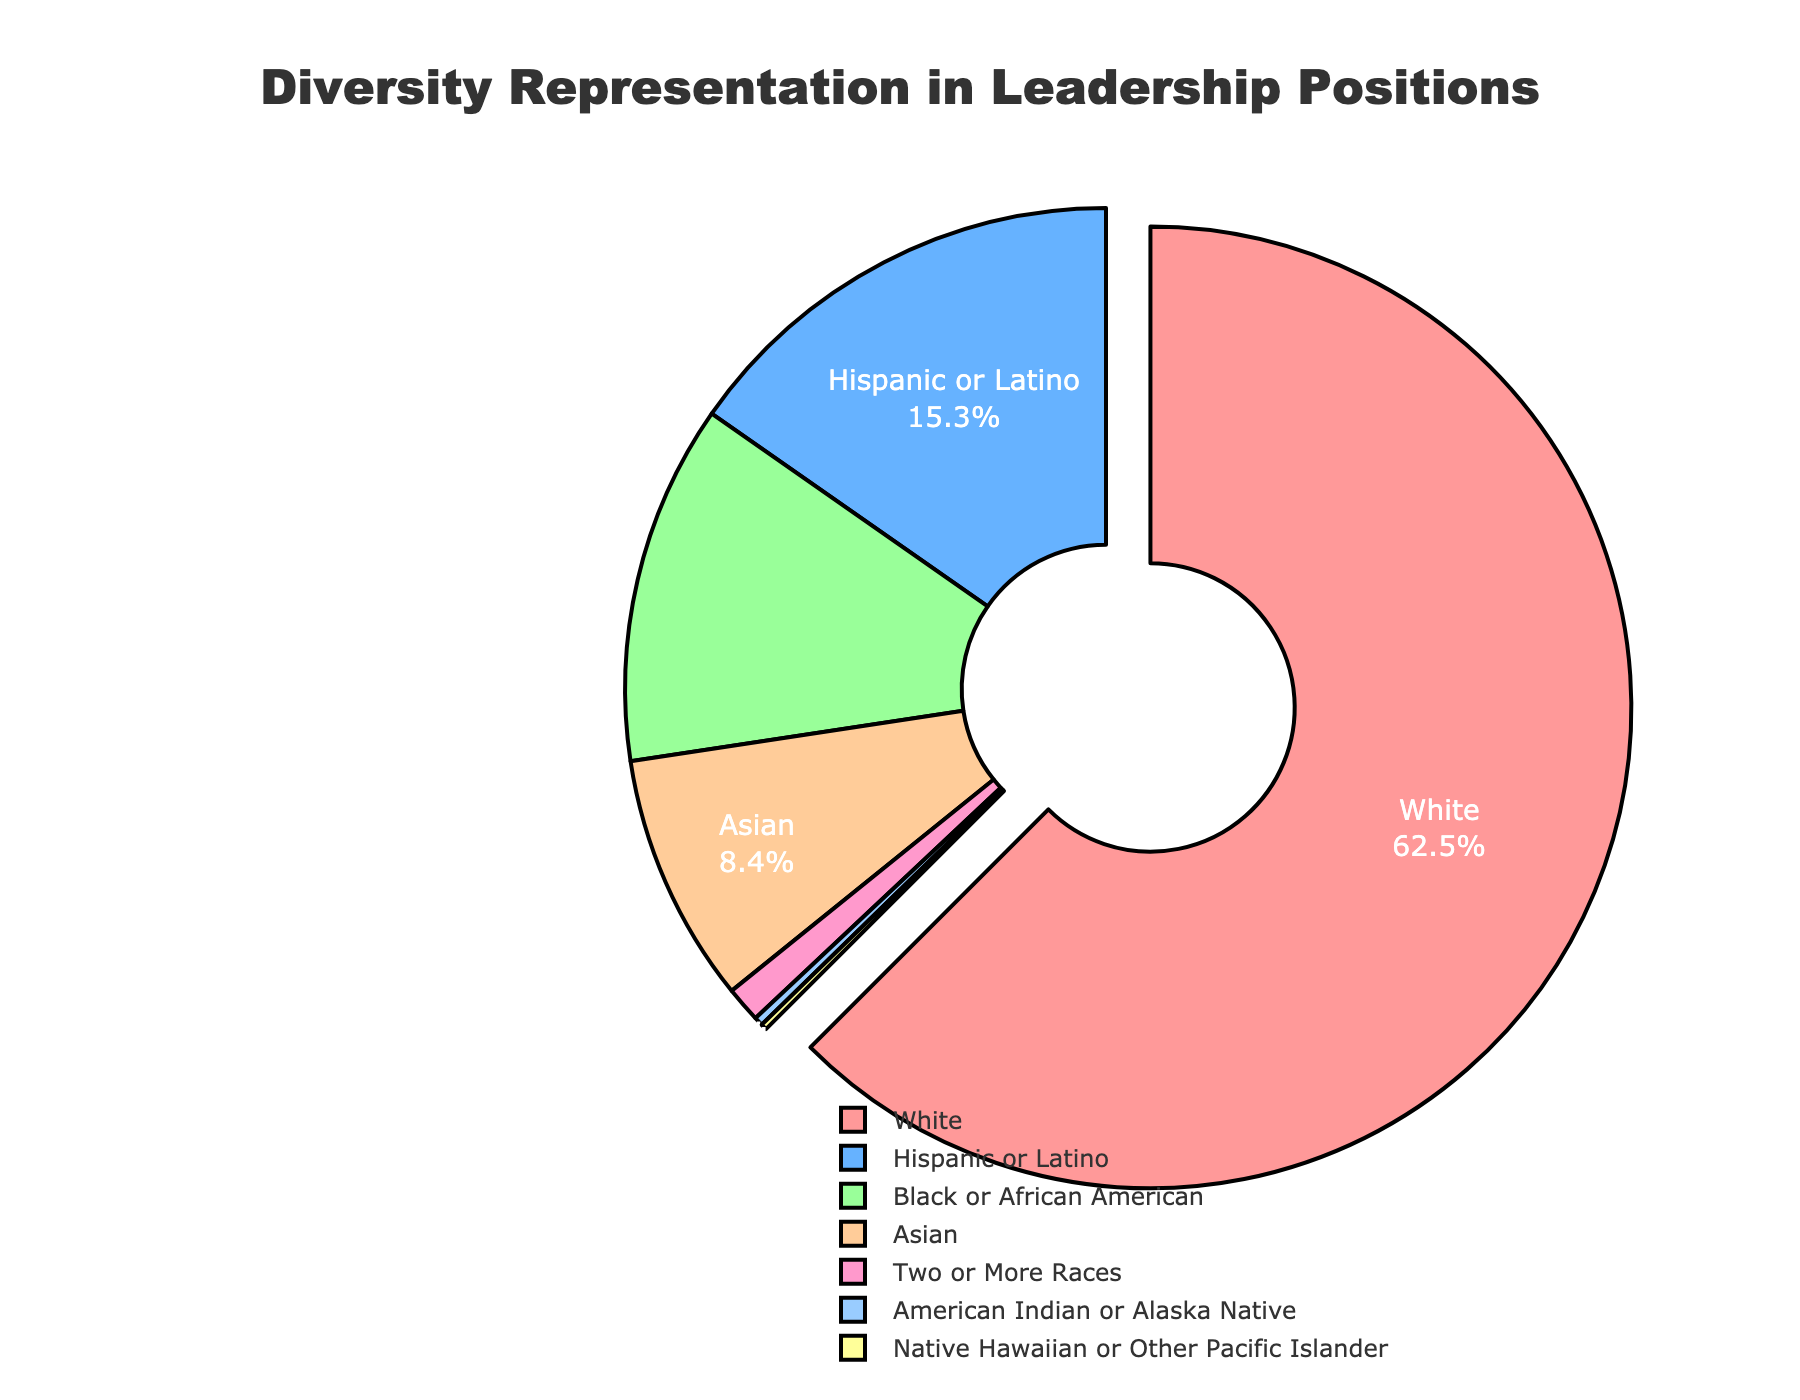What is the percentage of leadership positions held by White individuals? The figure shows a pie chart with different segments representing various race/ethnicity categories. The segment labeled "White" shows the percentage of leadership positions held by individuals in this category.
Answer: 62.5% Which group has the smallest representation in leadership positions? By examining the pie chart, the segment for "Native Hawaiian or Other Pacific Islander" is the smallest, indicating it has the least representation.
Answer: Native Hawaiian or Other Pacific Islander How does the representation of Asian individuals compare to that of Black or African American individuals? Comparing the pie chart segments, the "Asian" segment accounts for 8.4% while the "Black or African American" segment accounts for 12.1%. Therefore, Asian representation is lower than Black or African American representation.
Answer: Asian representation is lower What is the combined percentage representation of Hispanic or Latino and Black or African American individuals in leadership positions? Add the percentage of the Hispanic or Latino segment (15.3%) to the percentage of the Black or African American segment (12.1%). 15.3% + 12.1% = 27.4%
Answer: 27.4% Which demographic group is visually highlighted in the pie chart, and what is its representation percentage? The group visually pulled out from the pie chart is the one with the maximum representation. The segment "White" is pulled out, indicating it is highlighted, and its representation percentage is 62.5%.
Answer: White, 62.5% What is the difference in representation between the group with the highest percentage and the group with the second-highest percentage? The highest percentage group is "White" with 62.5%, and the second-highest is "Hispanic or Latino" with 15.3%. The difference is 62.5% - 15.3% = 47.2%
Answer: 47.2% What proportion of the total does the "Asian" and "Two or More Races" categories together constitute? Add the percentage of the Asian segment (8.4%) to the percentage of the Two or More Races segment (1.2%). 8.4% + 1.2% = 9.6%
Answer: 9.6% If the pie chart were redrawn to exclude the "White" category, what would be the largest group, and what would its new percentage be? Without the "White" category, the total percentage is 100% - 62.5% = 37.5%. The largest remaining group is "Hispanic or Latino" with 15.3%. To find the new percentage for "Hispanic or Latino": (15.3 / 37.5) * 100% = 40.8%
Answer: Hispanic or Latino, 40.8% How many categories in the pie chart have a representation below 5%? Observing the pie chart, the "Two or More Races" (1.2%), "American Indian or Alaska Native" (0.3%), and "Native Hawaiian or Other Pacific Islander" (0.2%) categories each have percentages below 5%. That totals to three categories.
Answer: 3 